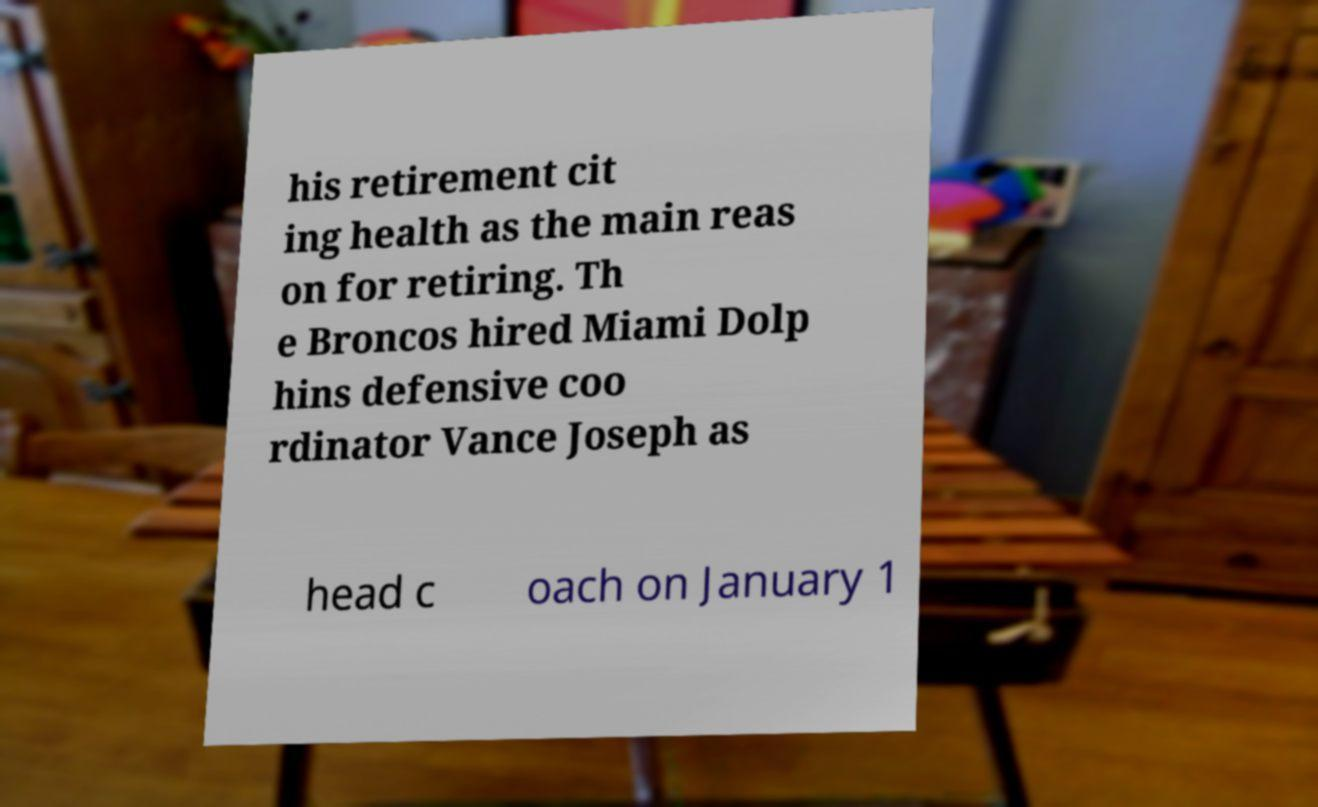For documentation purposes, I need the text within this image transcribed. Could you provide that? his retirement cit ing health as the main reas on for retiring. Th e Broncos hired Miami Dolp hins defensive coo rdinator Vance Joseph as head c oach on January 1 